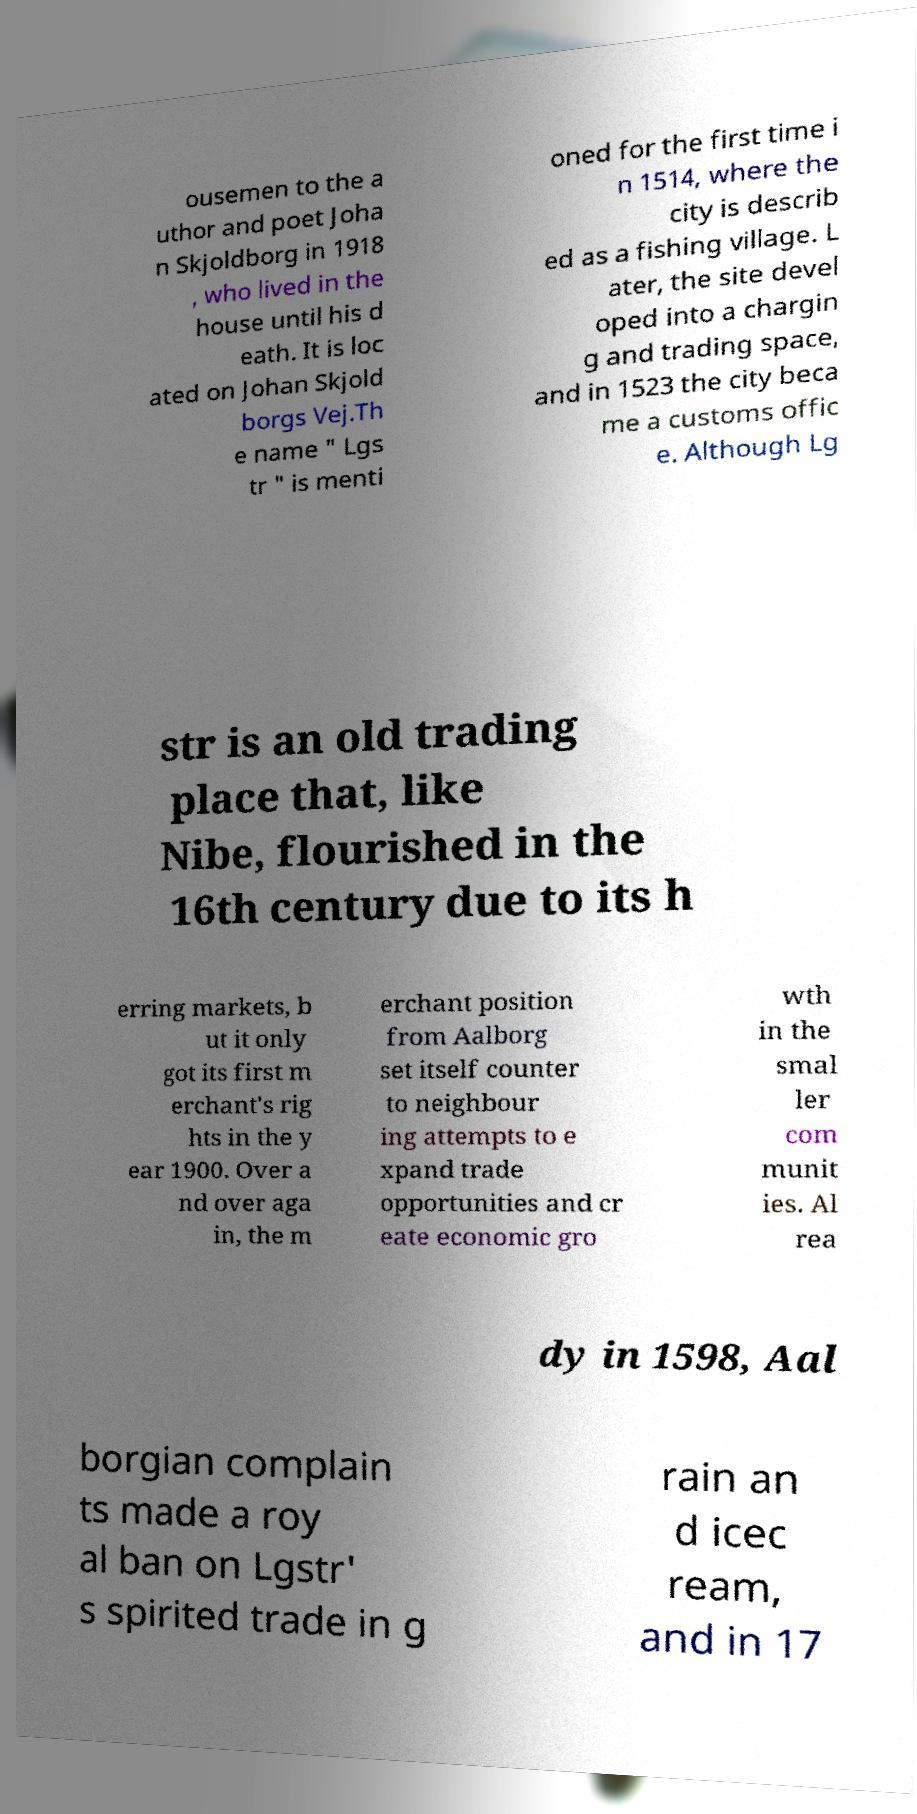Could you extract and type out the text from this image? ousemen to the a uthor and poet Joha n Skjoldborg in 1918 , who lived in the house until his d eath. It is loc ated on Johan Skjold borgs Vej.Th e name " Lgs tr " is menti oned for the first time i n 1514, where the city is describ ed as a fishing village. L ater, the site devel oped into a chargin g and trading space, and in 1523 the city beca me a customs offic e. Although Lg str is an old trading place that, like Nibe, flourished in the 16th century due to its h erring markets, b ut it only got its first m erchant's rig hts in the y ear 1900. Over a nd over aga in, the m erchant position from Aalborg set itself counter to neighbour ing attempts to e xpand trade opportunities and cr eate economic gro wth in the smal ler com munit ies. Al rea dy in 1598, Aal borgian complain ts made a roy al ban on Lgstr' s spirited trade in g rain an d icec ream, and in 17 